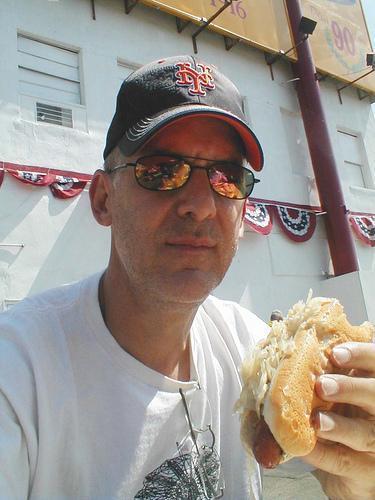Evaluate: Does the caption "The person is away from the sandwich." match the image?
Answer yes or no. No. 